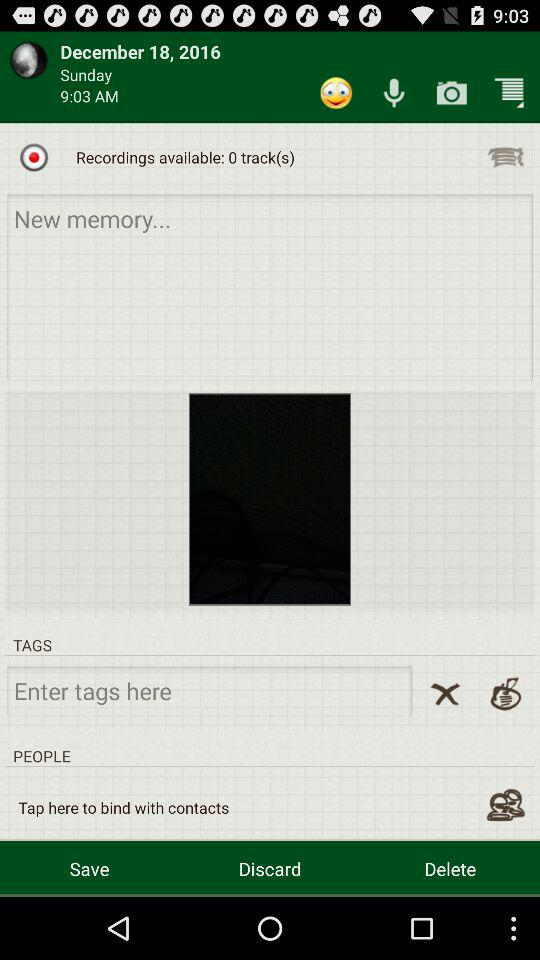What is the weekday of recording? The weekday of the recording is Sunday. 